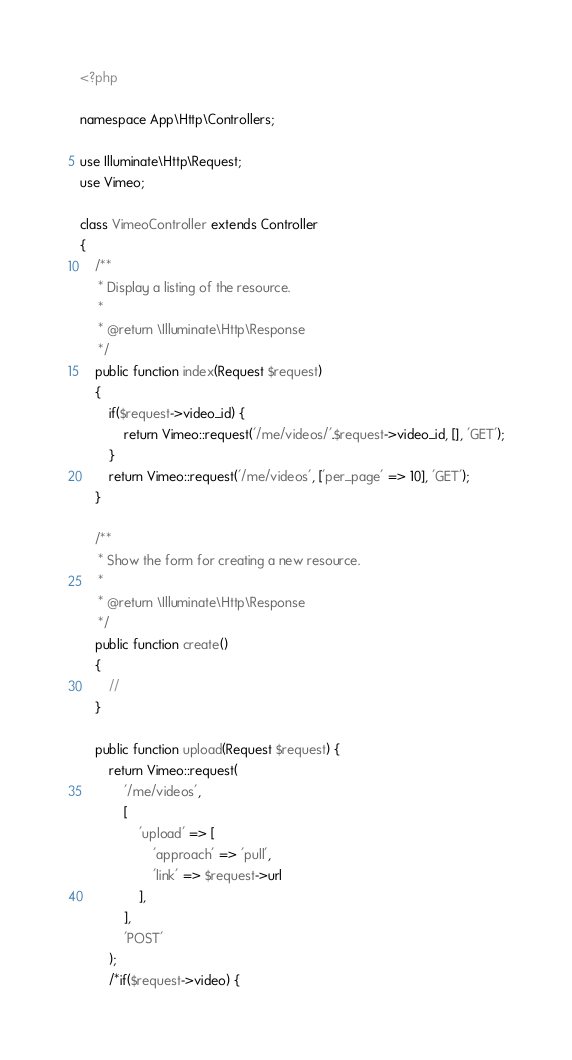<code> <loc_0><loc_0><loc_500><loc_500><_PHP_><?php

namespace App\Http\Controllers;

use Illuminate\Http\Request;
use Vimeo;

class VimeoController extends Controller
{
    /**
     * Display a listing of the resource.
     *
     * @return \Illuminate\Http\Response
     */
    public function index(Request $request)
    {
        if($request->video_id) {
            return Vimeo::request('/me/videos/'.$request->video_id, [], 'GET');
        }
        return Vimeo::request('/me/videos', ['per_page' => 10], 'GET');
    }

    /**
     * Show the form for creating a new resource.
     *
     * @return \Illuminate\Http\Response
     */
    public function create()
    {
        //
    }

    public function upload(Request $request) {
        return Vimeo::request(
            '/me/videos',
            [
                'upload' => [
                    'approach' => 'pull',
                    'link' => $request->url
                ],
            ],
            'POST'
        );
        /*if($request->video) {</code> 